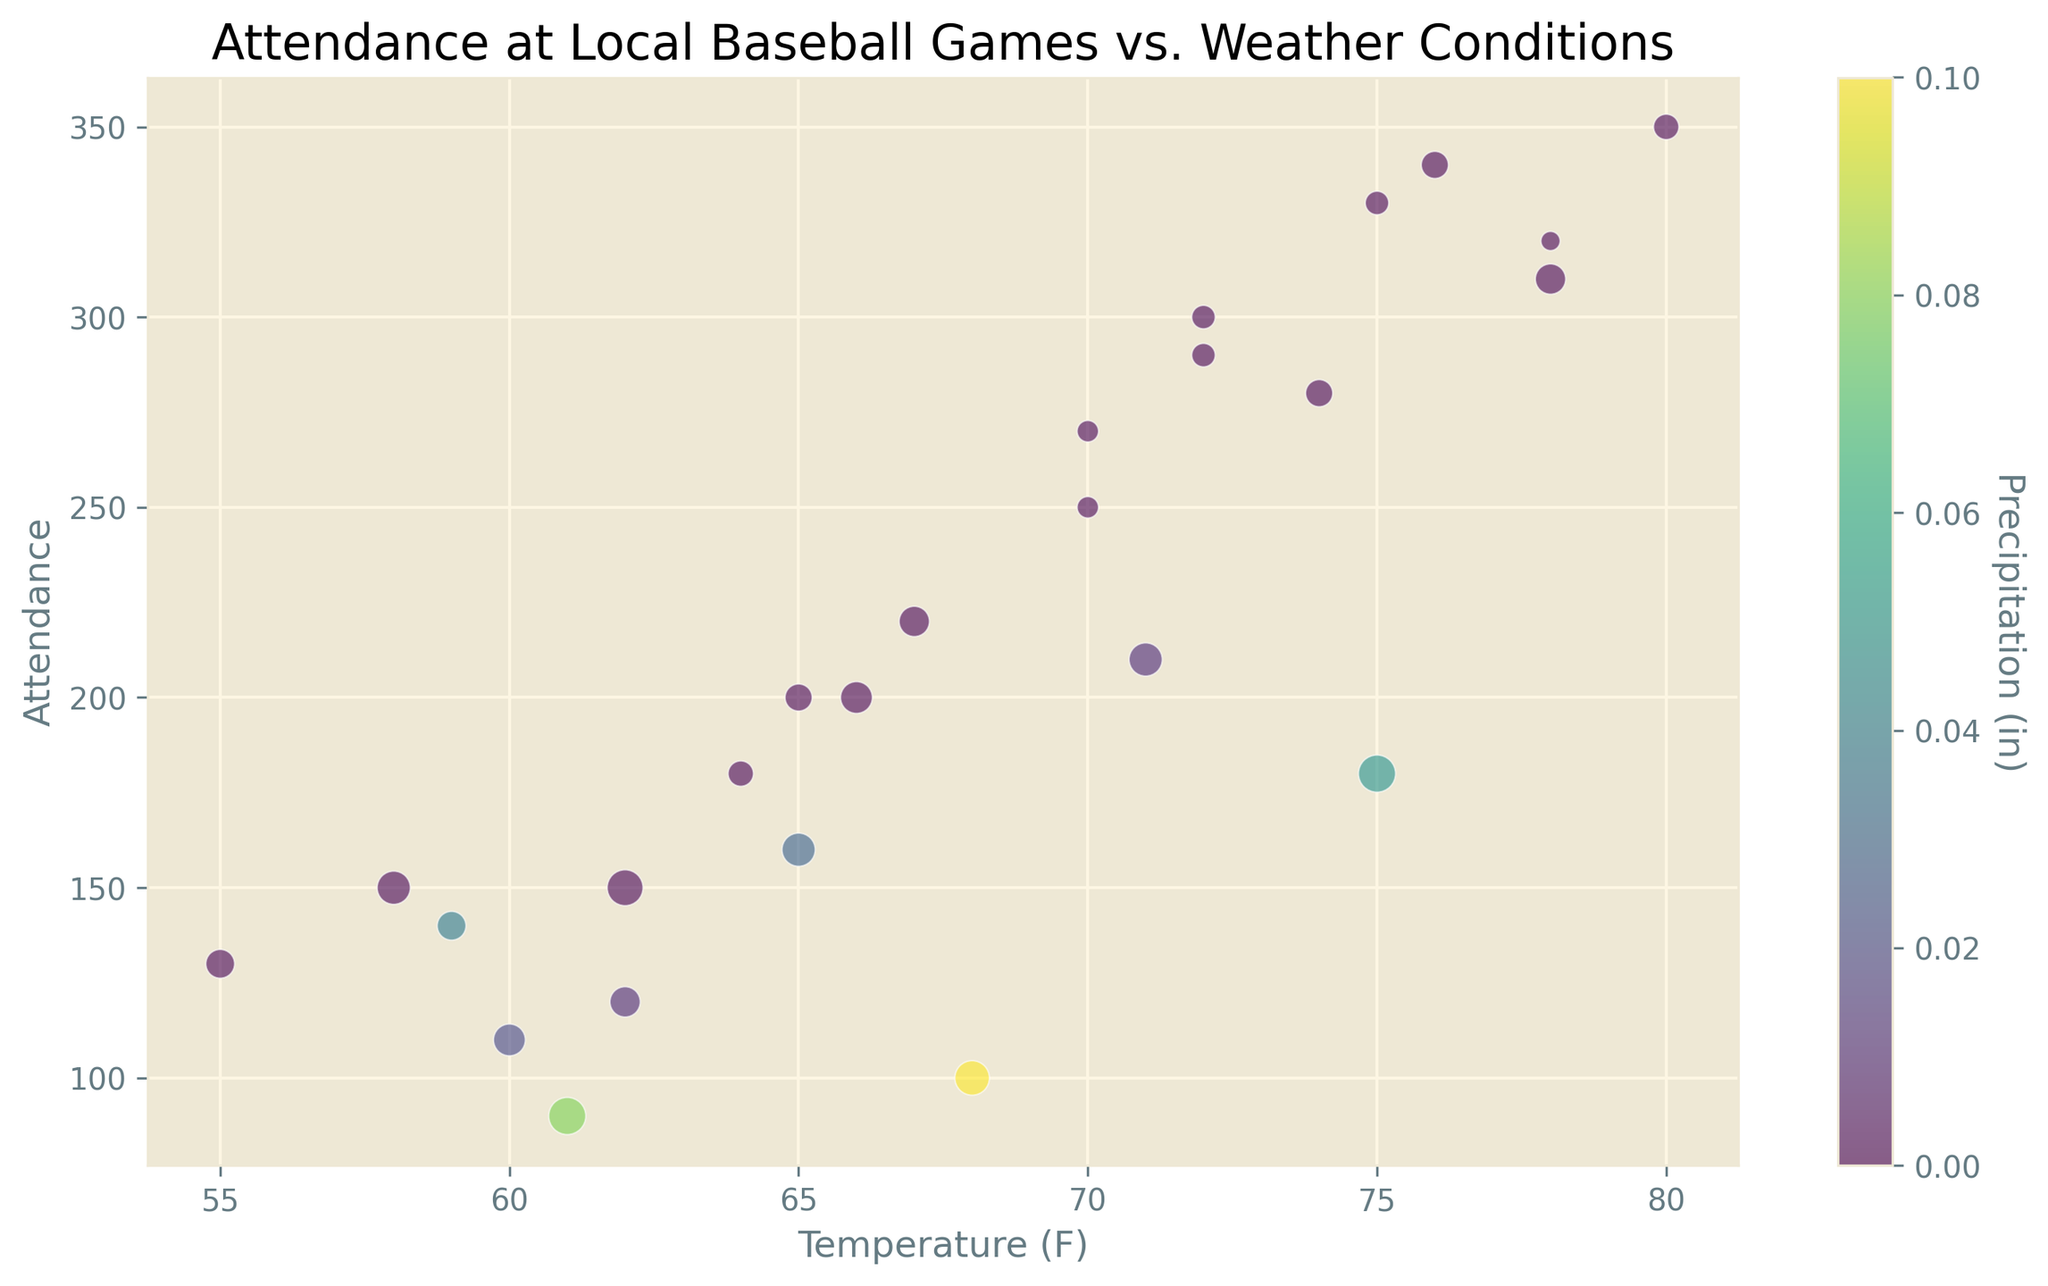What's the temperature range where attendance appears highest? To identify this, we look for the temperature values where the highest attendance dots cluster. The highest attendance points visibly occur around the 70°F to 80°F range.
Answer: 70°F to 80°F What color represents the highest precipitation and what's the attendance level at that point? The color scale indicates higher precipitation in shades closer to green. The attendance point around 90 has a distinctly green hue, representing 0.08 inches of precipitation.
Answer: Green, 90 Does wind speed affect attendance more or less compared to precipitation, based on the plot? By observing the size variations representing wind speed and color changes for precipitation, it seems larger dot sizes (higher wind speeds) are often associated with lower attendance, more consistently than the color variations for precipitation.
Answer: Wind speed affects it more Which day had the highest attendance, and what were the weather conditions? The top attendance category is higher than 300. Inspecting data points in this range, a high dot on the far right represents a high attendance (~350) on a day with ~80°F temperature, low wind speed (~7 mph), and close to no precipitation.
Answer: 80°F, ~7 mph, 0.00 in Compare the attendance between days with no precipitation and slight precipitation (0.01-0.05 inches). Attendance tends to be higher on days with no precipitation. For example, days around 75°F with no precipitation have higher attendance compared to days around the same temperature but with 0.01-0.05 inches of precipitation.
Answer: Higher with no precipitation On days with temperatures below 60°F, how is the attendance overall? Inspecting the plot for dots below the 60°F mark, the points are generally lower on the attendance scale, suggesting overall lower attendance.
Answer: Low Is there any noticeable trend in attendance with increasing temperature? As temperatures increase from 55°F to 80°F, there is a general trend of rising attendance, which peaks around 80°F. This suggests a positive correlation between temperature and attendance up until 80°F.
Answer: Increasing trend What wind speed was most common on high attendance days (above 300 attendees)? For the highest attendance days, the plot shows medium-sized dots, indicating moderate wind speeds around 6-10 mph.
Answer: 6-10 mph How does attendance vary on clear days vs. rainy days? Clear days without precipitation (yellowish dots) consistently show higher attendance compared to dots with shades of green or darker (rainy days).
Answer: Higher on clear days 